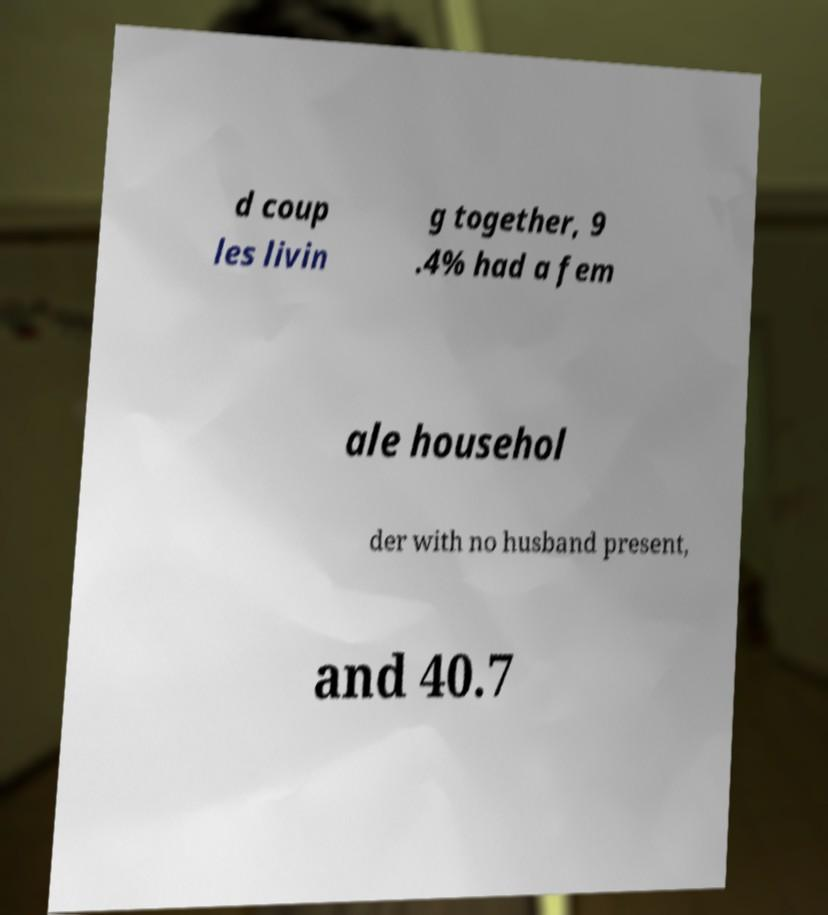Can you accurately transcribe the text from the provided image for me? d coup les livin g together, 9 .4% had a fem ale househol der with no husband present, and 40.7 